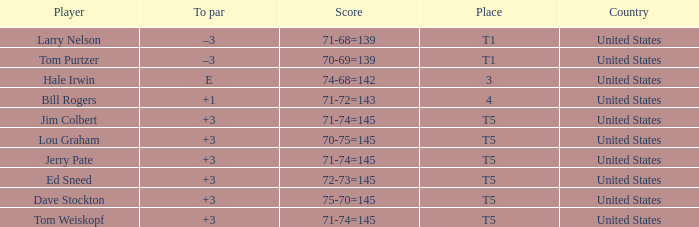What is the to par of player ed sneed, who has a t5 place? 3.0. Parse the full table. {'header': ['Player', 'To par', 'Score', 'Place', 'Country'], 'rows': [['Larry Nelson', '–3', '71-68=139', 'T1', 'United States'], ['Tom Purtzer', '–3', '70-69=139', 'T1', 'United States'], ['Hale Irwin', 'E', '74-68=142', '3', 'United States'], ['Bill Rogers', '+1', '71-72=143', '4', 'United States'], ['Jim Colbert', '+3', '71-74=145', 'T5', 'United States'], ['Lou Graham', '+3', '70-75=145', 'T5', 'United States'], ['Jerry Pate', '+3', '71-74=145', 'T5', 'United States'], ['Ed Sneed', '+3', '72-73=145', 'T5', 'United States'], ['Dave Stockton', '+3', '75-70=145', 'T5', 'United States'], ['Tom Weiskopf', '+3', '71-74=145', 'T5', 'United States']]} 